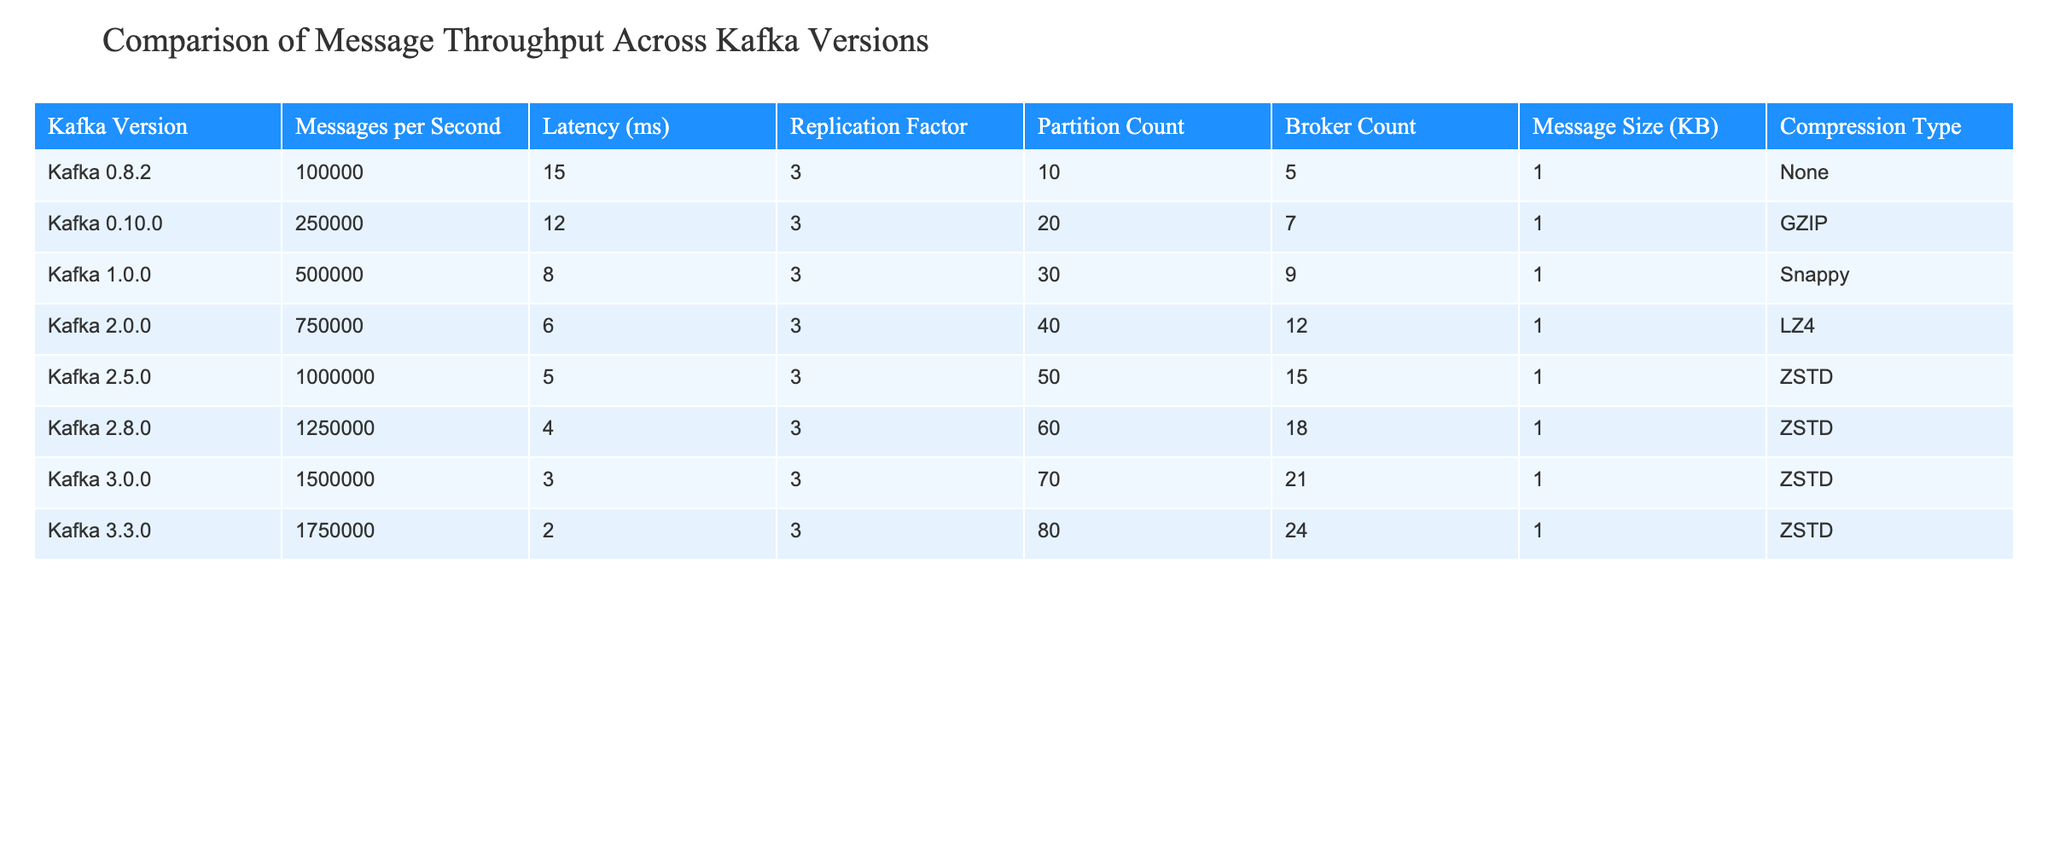What is the message throughput of Kafka version 2.0.0? The table indicates that the message throughput for Kafka version 2.0.0 is 750,000 messages per second.
Answer: 750,000 Which Kafka version has the lowest latency? According to the table, Kafka version 3.3.0 has the lowest latency at 2 ms.
Answer: 3.3.0 What is the difference in messages per second between Kafka version 1.0.0 and Kafka version 2.5.0? The message throughput of Kafka 1.0.0 is 500,000 messages per second and for Kafka 2.5.0, it is 1,000,000 messages per second. The difference is 1,000,000 - 500,000 = 500,000 messages per second.
Answer: 500,000 Is it true that Kafka version 2.8.0 has a higher message throughput than Kafka version 2.0.0? Checking the table, Kafka version 2.8.0 has a throughput of 1,250,000 messages per second, which is indeed higher than the 750,000 messages per second for Kafka version 2.0.0. Therefore, the statement is true.
Answer: True What is the average latency of Kafka versions 0.8.2, 1.0.0, and 3.0.0? The latencies are 15 ms, 8 ms, and 3 ms respectively. The total latency is 15 + 8 + 3 = 26 ms, and there are 3 versions, so the average is 26 / 3 = approximately 8.67 ms.
Answer: 8.67 Which Kafka version has the highest replication factor, and what is its value? The table shows that all listed versions have a replication factor of 3. Thus, the highest replication factor remains the same across all versions, which is 3.
Answer: 3 What is the total number of messages per second across all Kafka versions listed? To find the total, we add each version's throughput: 100,000 + 250,000 + 500,000 + 750,000 + 1,000,000 + 1,250,000 + 1,500,000 + 1,750,000 = 5,250,000 messages per second.
Answer: 5,250,000 How much does the message size increase from Kafka version 0.8.2 to 3.3.0? The message size for Kafka 0.8.2 is 1 KB, and for Kafka 3.3.0, it is 24 KB. The increase is 24 - 1 = 23 KB.
Answer: 23 KB Is the compression type consistent across all versions of Kafka? Examining the table, it is clear that the compression type varies among versions; therefore, it is not consistent.
Answer: No What is the trend in message throughput as the Kafka versions progress? By reviewing the table, we see an increasing trend in message throughput, starting from 100,000 in version 0.8.2 to 1,750,000 in version 3.3.0.
Answer: Increasing 